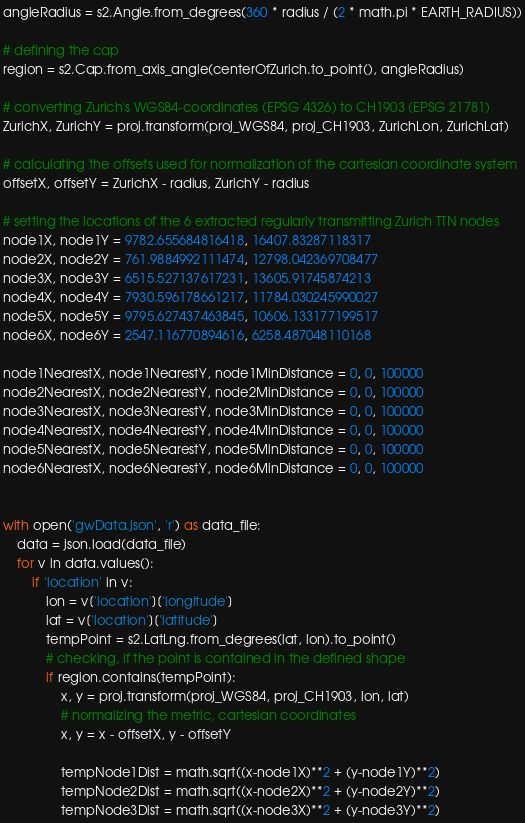Convert code to text. <code><loc_0><loc_0><loc_500><loc_500><_Python_>angleRadius = s2.Angle.from_degrees(360 * radius / (2 * math.pi * EARTH_RADIUS))

# defining the cap
region = s2.Cap.from_axis_angle(centerOfZurich.to_point(), angleRadius)

# converting Zurich's WGS84-coordinates (EPSG 4326) to CH1903 (EPSG 21781)
ZurichX, ZurichY = proj.transform(proj_WGS84, proj_CH1903, ZurichLon, ZurichLat)

# calculating the offsets used for normalization of the cartesian coordinate system
offsetX, offsetY = ZurichX - radius, ZurichY - radius

# setting the locations of the 6 extracted regularly transmitting Zurich TTN nodes
node1X, node1Y = 9782.655684816418, 16407.83287118317
node2X, node2Y = 761.9884992111474, 12798.042369708477
node3X, node3Y = 6515.527137617231, 13605.91745874213
node4X, node4Y = 7930.596178661217, 11784.030245990027
node5X, node5Y = 9795.627437463845, 10606.133177199517
node6X, node6Y = 2547.116770894616, 6258.487048110168

node1NearestX, node1NearestY, node1MinDistance = 0, 0, 100000
node2NearestX, node2NearestY, node2MinDistance = 0, 0, 100000
node3NearestX, node3NearestY, node3MinDistance = 0, 0, 100000
node4NearestX, node4NearestY, node4MinDistance = 0, 0, 100000
node5NearestX, node5NearestY, node5MinDistance = 0, 0, 100000
node6NearestX, node6NearestY, node6MinDistance = 0, 0, 100000


with open('gwData.json', 'r') as data_file:
	data = json.load(data_file)
	for v in data.values():
		if 'location' in v:
			lon = v['location']['longitude']
			lat = v['location']['latitude']
			tempPoint = s2.LatLng.from_degrees(lat, lon).to_point()
			# checking, if the point is contained in the defined shape
			if region.contains(tempPoint):
				x, y = proj.transform(proj_WGS84, proj_CH1903, lon, lat)
				# normalizing the metric, cartesian coordinates
				x, y = x - offsetX, y - offsetY

				tempNode1Dist = math.sqrt((x-node1X)**2 + (y-node1Y)**2)
				tempNode2Dist = math.sqrt((x-node2X)**2 + (y-node2Y)**2)
				tempNode3Dist = math.sqrt((x-node3X)**2 + (y-node3Y)**2)</code> 